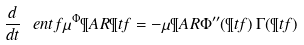Convert formula to latex. <formula><loc_0><loc_0><loc_500><loc_500>\frac { d } { d t } \ e n t f { \mu } ^ { \Phi } \P A R { \P t f } = - \mu \P A R { \Phi ^ { \prime \prime } ( \P t f ) \, \Gamma ( \P t f ) }</formula> 